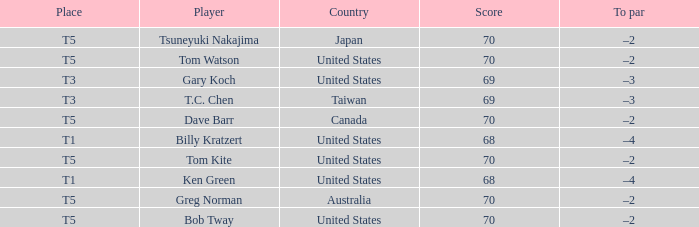What is the lowest score that Bob Tway get when he placed t5? 70.0. 